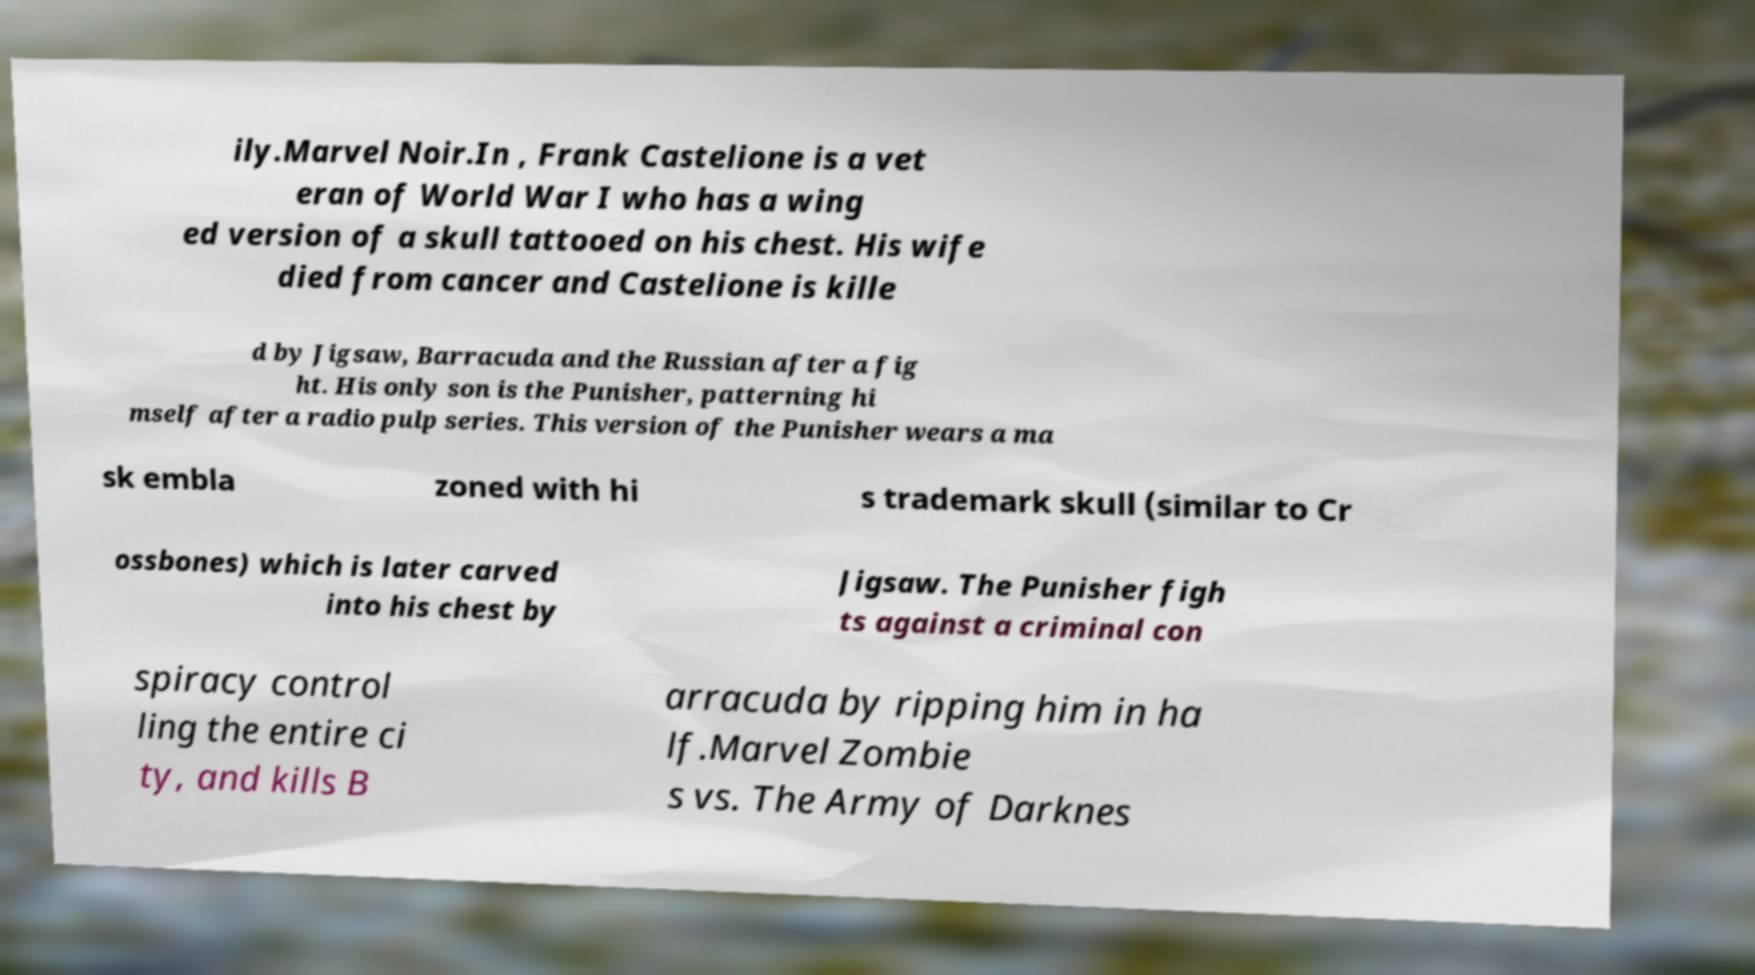Can you accurately transcribe the text from the provided image for me? ily.Marvel Noir.In , Frank Castelione is a vet eran of World War I who has a wing ed version of a skull tattooed on his chest. His wife died from cancer and Castelione is kille d by Jigsaw, Barracuda and the Russian after a fig ht. His only son is the Punisher, patterning hi mself after a radio pulp series. This version of the Punisher wears a ma sk embla zoned with hi s trademark skull (similar to Cr ossbones) which is later carved into his chest by Jigsaw. The Punisher figh ts against a criminal con spiracy control ling the entire ci ty, and kills B arracuda by ripping him in ha lf.Marvel Zombie s vs. The Army of Darknes 